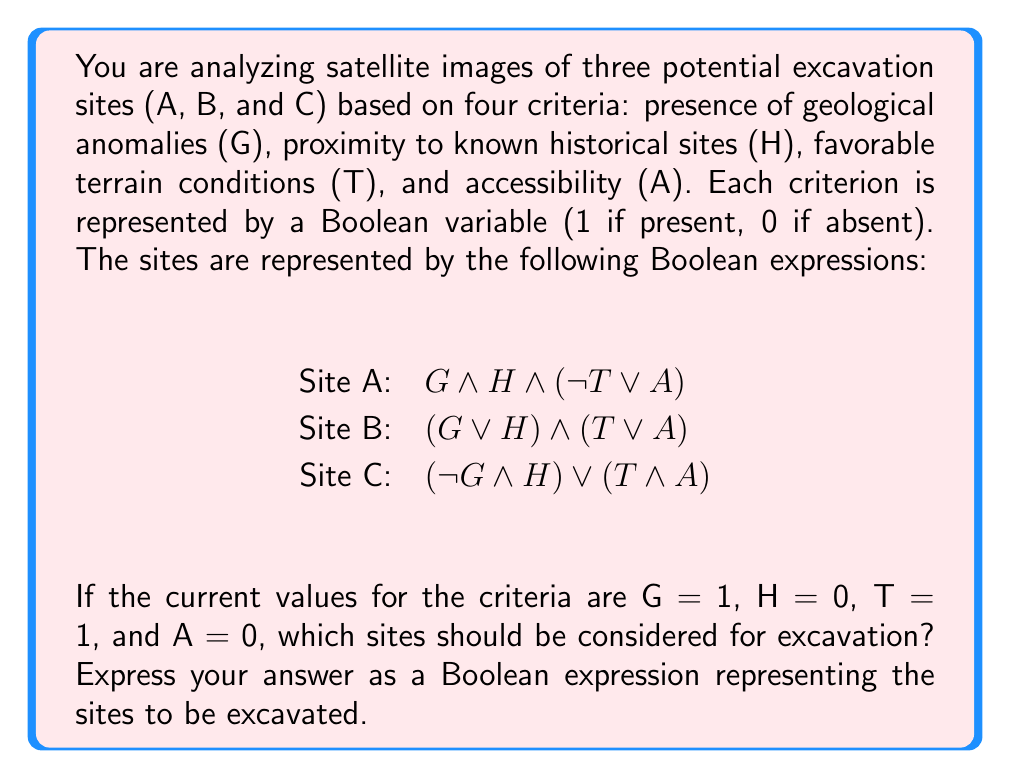Provide a solution to this math problem. To solve this problem, we need to evaluate each site's Boolean expression using the given values:

G = 1 (True)
H = 0 (False)
T = 1 (True)
A = 0 (False)

Let's evaluate each site:

1. Site A: $G \land H \land (\neg T \lor A)$
   $= 1 \land 0 \land (\neg 1 \lor 0)$
   $= 1 \land 0 \land (0 \lor 0)$
   $= 1 \land 0 \land 0$
   $= 0$ (False)

2. Site B: $(G \lor H) \land (T \lor A)$
   $= (1 \lor 0) \land (1 \lor 0)$
   $= 1 \land 1$
   $= 1$ (True)

3. Site C: $(\neg G \land H) \lor (T \land A)$
   $= (\neg 1 \land 0) \lor (1 \land 0)$
   $= (0 \land 0) \lor 0$
   $= 0 \lor 0$
   $= 0$ (False)

Based on these evaluations, only Site B should be considered for excavation. We can represent this result as a Boolean expression using variables A, B, and C to represent each site:

$\neg A \land B \land \neg C$

This expression is true only when B is true and both A and C are false, which matches our evaluation results.
Answer: $\neg A \land B \land \neg C$ 